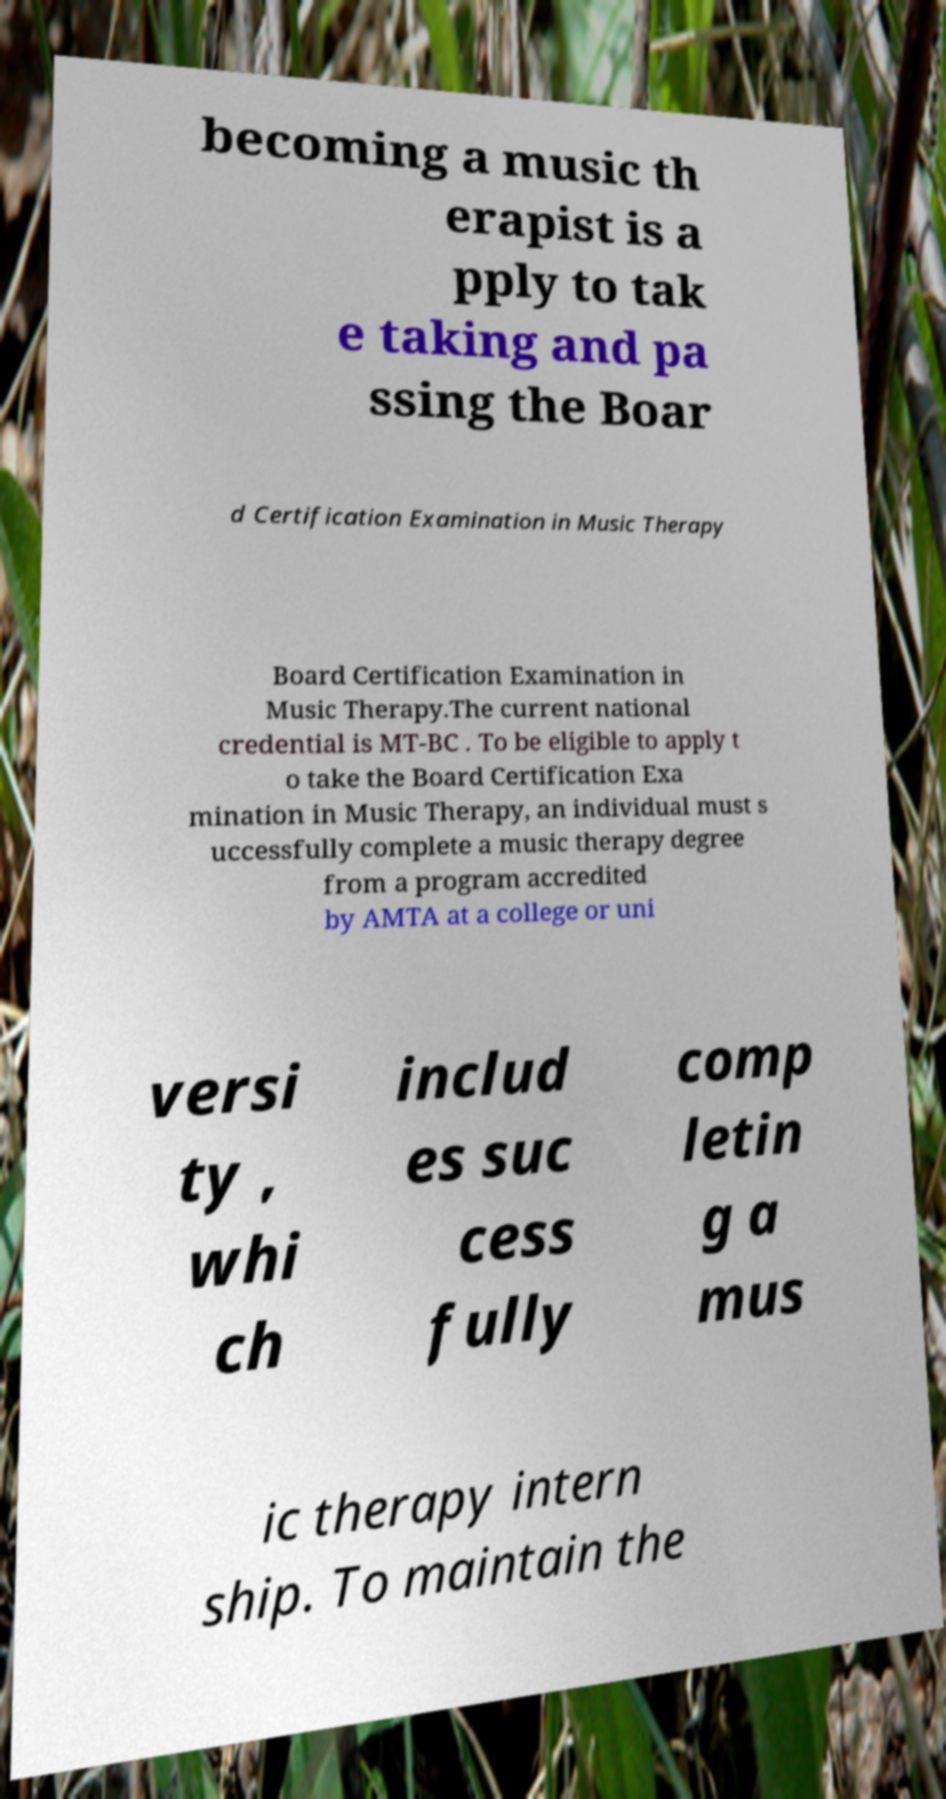Can you read and provide the text displayed in the image?This photo seems to have some interesting text. Can you extract and type it out for me? becoming a music th erapist is a pply to tak e taking and pa ssing the Boar d Certification Examination in Music Therapy Board Certification Examination in Music Therapy.The current national credential is MT-BC . To be eligible to apply t o take the Board Certification Exa mination in Music Therapy, an individual must s uccessfully complete a music therapy degree from a program accredited by AMTA at a college or uni versi ty , whi ch includ es suc cess fully comp letin g a mus ic therapy intern ship. To maintain the 